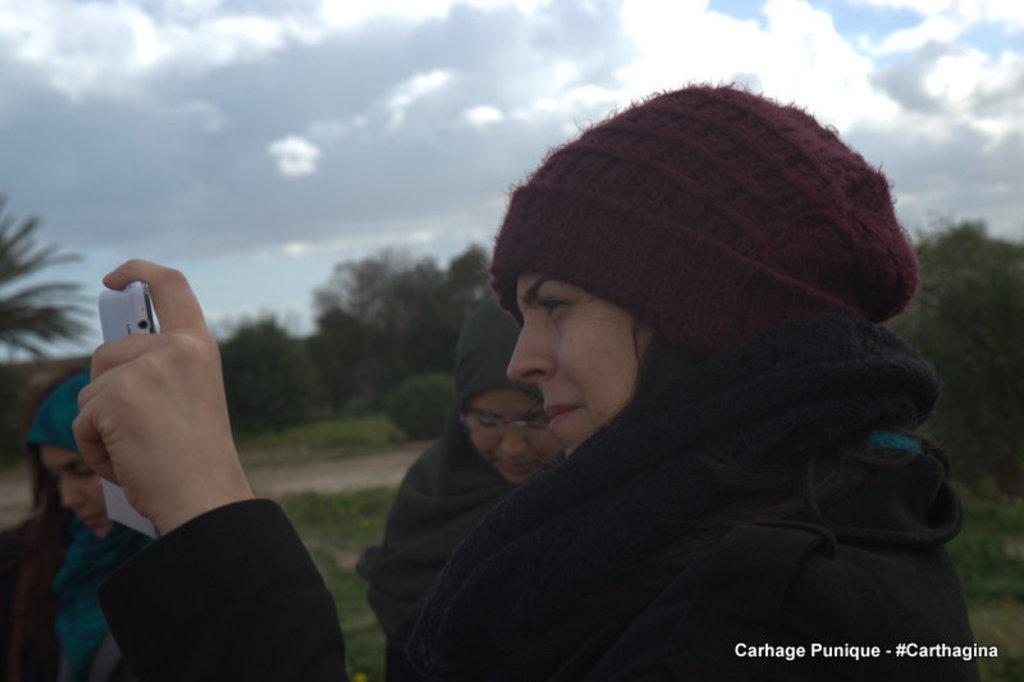In one or two sentences, can you explain what this image depicts? In this image I can see 3 women standing and one of them is wearing a cap which is of maroon in color and she is holding an electronic device. In the background I can see few plants and few trees and I can also see the sky is a bit cloudy and blue in color. 